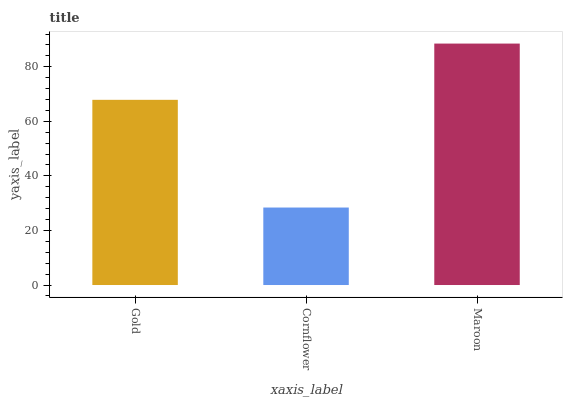Is Cornflower the minimum?
Answer yes or no. Yes. Is Maroon the maximum?
Answer yes or no. Yes. Is Maroon the minimum?
Answer yes or no. No. Is Cornflower the maximum?
Answer yes or no. No. Is Maroon greater than Cornflower?
Answer yes or no. Yes. Is Cornflower less than Maroon?
Answer yes or no. Yes. Is Cornflower greater than Maroon?
Answer yes or no. No. Is Maroon less than Cornflower?
Answer yes or no. No. Is Gold the high median?
Answer yes or no. Yes. Is Gold the low median?
Answer yes or no. Yes. Is Maroon the high median?
Answer yes or no. No. Is Maroon the low median?
Answer yes or no. No. 